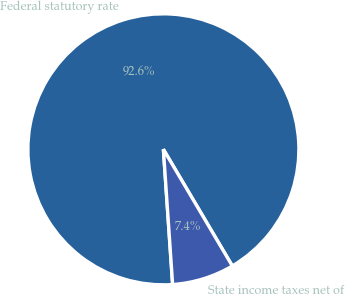Convert chart to OTSL. <chart><loc_0><loc_0><loc_500><loc_500><pie_chart><fcel>Federal statutory rate<fcel>State income taxes net of<nl><fcel>92.59%<fcel>7.41%<nl></chart> 